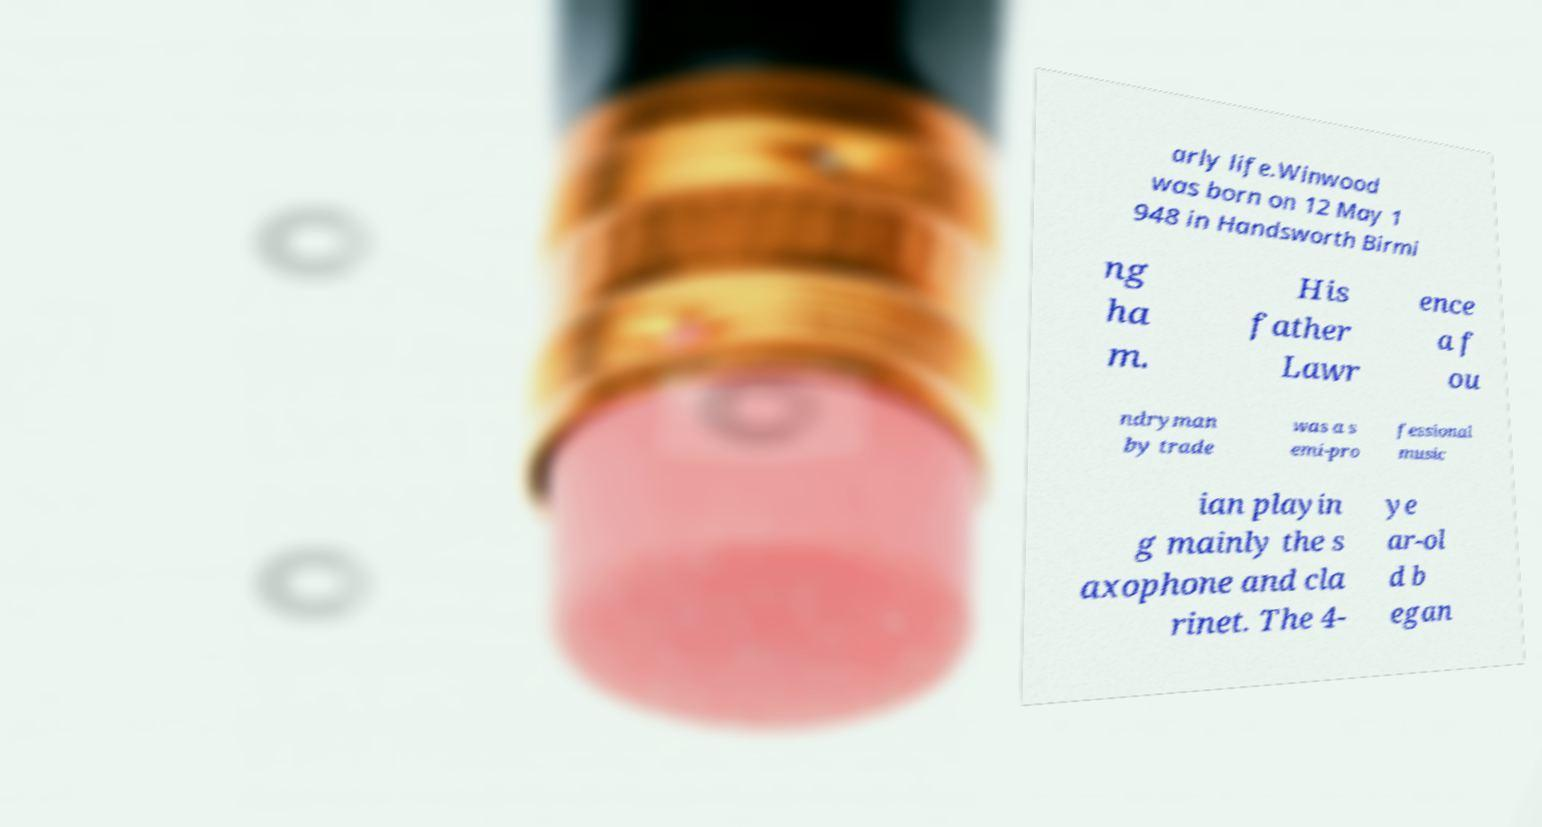What messages or text are displayed in this image? I need them in a readable, typed format. arly life.Winwood was born on 12 May 1 948 in Handsworth Birmi ng ha m. His father Lawr ence a f ou ndryman by trade was a s emi-pro fessional music ian playin g mainly the s axophone and cla rinet. The 4- ye ar-ol d b egan 